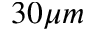<formula> <loc_0><loc_0><loc_500><loc_500>3 0 \mu m</formula> 